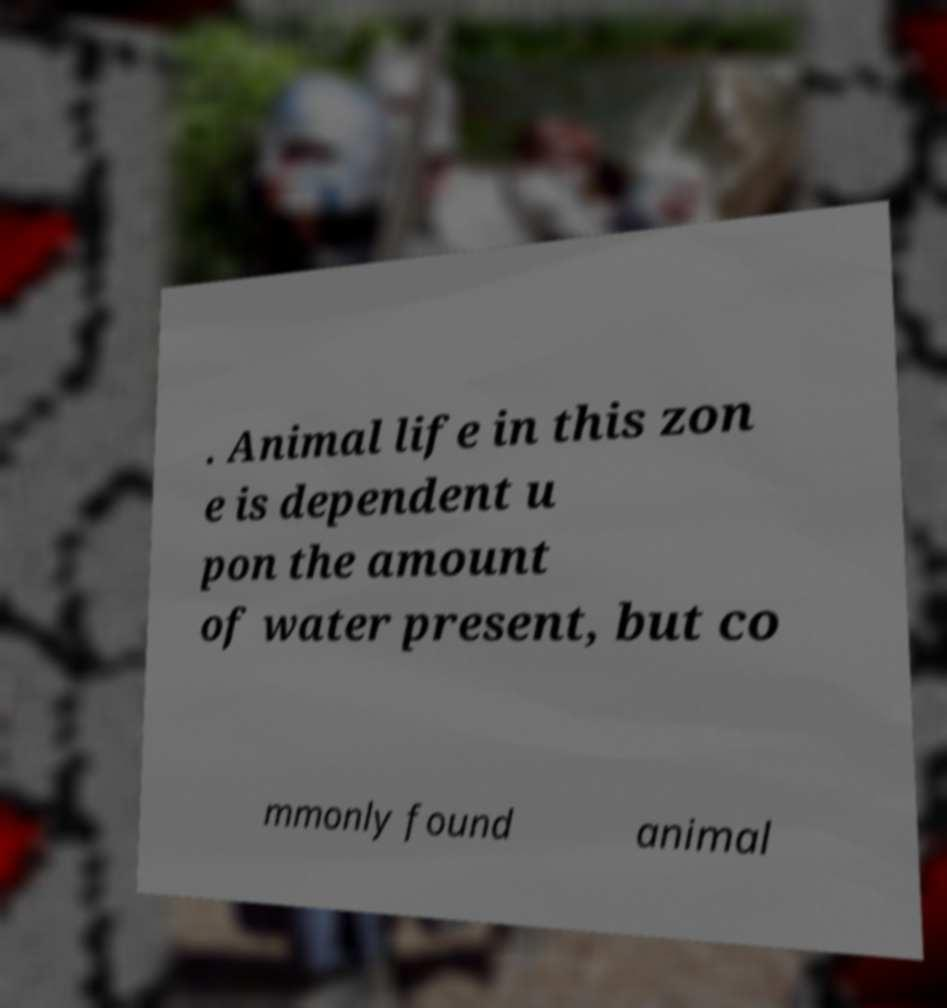Can you accurately transcribe the text from the provided image for me? . Animal life in this zon e is dependent u pon the amount of water present, but co mmonly found animal 